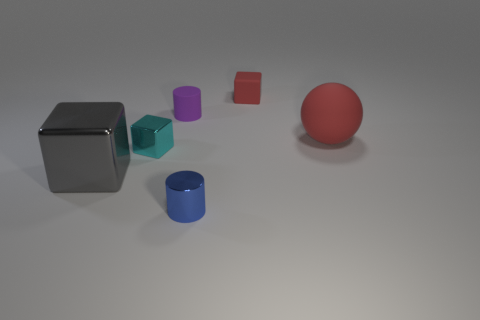Add 2 tiny blue metallic objects. How many objects exist? 8 Subtract all cylinders. How many objects are left? 4 Subtract all small green matte cubes. Subtract all purple cylinders. How many objects are left? 5 Add 5 tiny purple things. How many tiny purple things are left? 6 Add 5 large metallic cubes. How many large metallic cubes exist? 6 Subtract 1 blue cylinders. How many objects are left? 5 